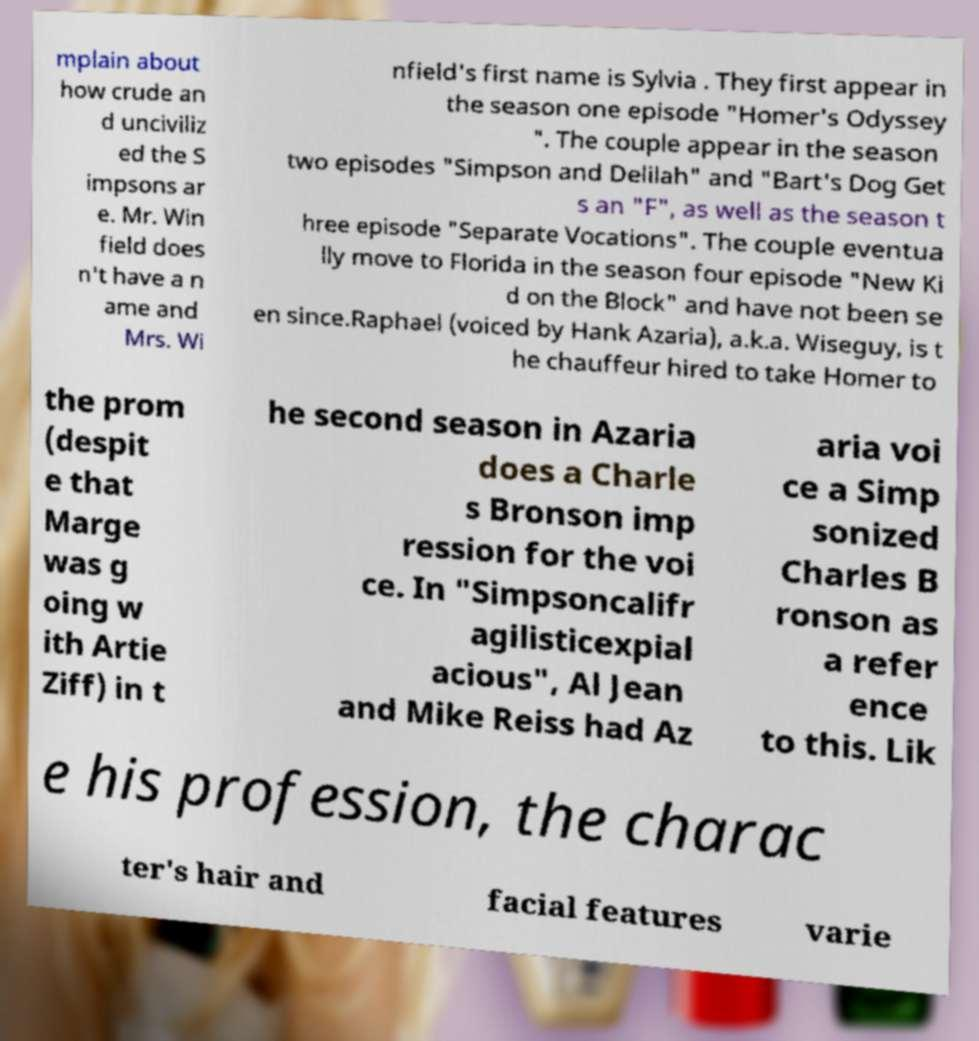Can you read and provide the text displayed in the image?This photo seems to have some interesting text. Can you extract and type it out for me? mplain about how crude an d unciviliz ed the S impsons ar e. Mr. Win field does n't have a n ame and Mrs. Wi nfield's first name is Sylvia . They first appear in the season one episode "Homer's Odyssey ". The couple appear in the season two episodes "Simpson and Delilah" and "Bart's Dog Get s an "F", as well as the season t hree episode "Separate Vocations". The couple eventua lly move to Florida in the season four episode "New Ki d on the Block" and have not been se en since.Raphael (voiced by Hank Azaria), a.k.a. Wiseguy, is t he chauffeur hired to take Homer to the prom (despit e that Marge was g oing w ith Artie Ziff) in t he second season in Azaria does a Charle s Bronson imp ression for the voi ce. In "Simpsoncalifr agilisticexpial acious", Al Jean and Mike Reiss had Az aria voi ce a Simp sonized Charles B ronson as a refer ence to this. Lik e his profession, the charac ter's hair and facial features varie 